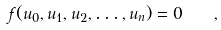<formula> <loc_0><loc_0><loc_500><loc_500>f ( u _ { 0 } , u _ { 1 } , u _ { 2 } , \dots , u _ { n } ) = 0 \quad ,</formula> 